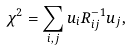<formula> <loc_0><loc_0><loc_500><loc_500>\chi ^ { 2 } = \sum _ { i , j } u _ { i } R _ { i j } ^ { - 1 } u _ { j } ,</formula> 